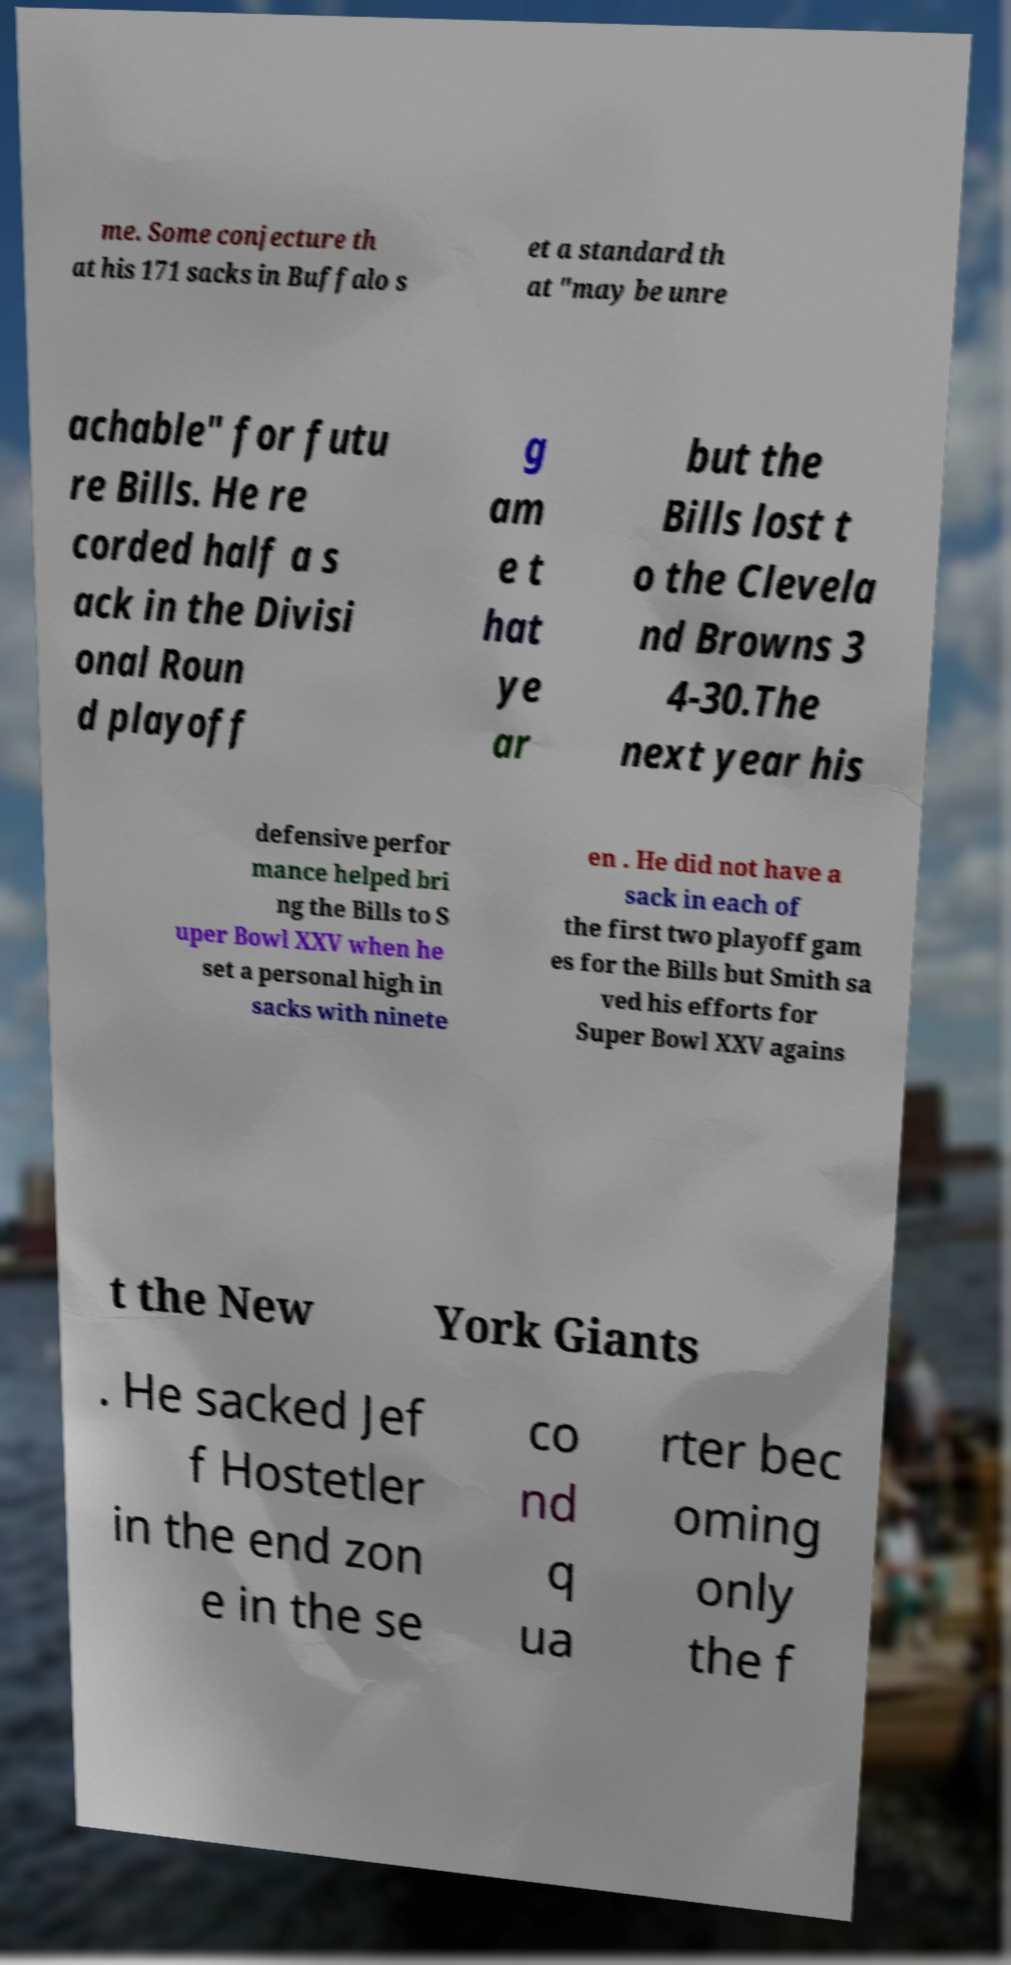For documentation purposes, I need the text within this image transcribed. Could you provide that? me. Some conjecture th at his 171 sacks in Buffalo s et a standard th at "may be unre achable" for futu re Bills. He re corded half a s ack in the Divisi onal Roun d playoff g am e t hat ye ar but the Bills lost t o the Clevela nd Browns 3 4-30.The next year his defensive perfor mance helped bri ng the Bills to S uper Bowl XXV when he set a personal high in sacks with ninete en . He did not have a sack in each of the first two playoff gam es for the Bills but Smith sa ved his efforts for Super Bowl XXV agains t the New York Giants . He sacked Jef f Hostetler in the end zon e in the se co nd q ua rter bec oming only the f 